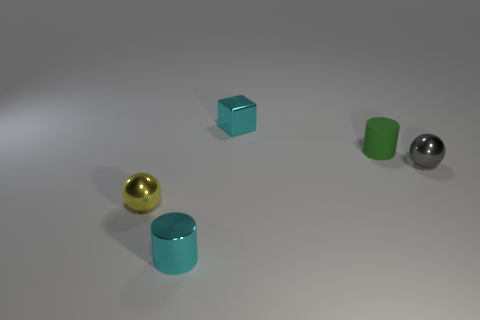Add 4 rubber objects. How many objects exist? 9 Subtract all spheres. How many objects are left? 3 Add 2 brown shiny cubes. How many brown shiny cubes exist? 2 Subtract 0 brown cylinders. How many objects are left? 5 Subtract all tiny yellow shiny balls. Subtract all matte objects. How many objects are left? 3 Add 5 tiny green rubber cylinders. How many tiny green rubber cylinders are left? 6 